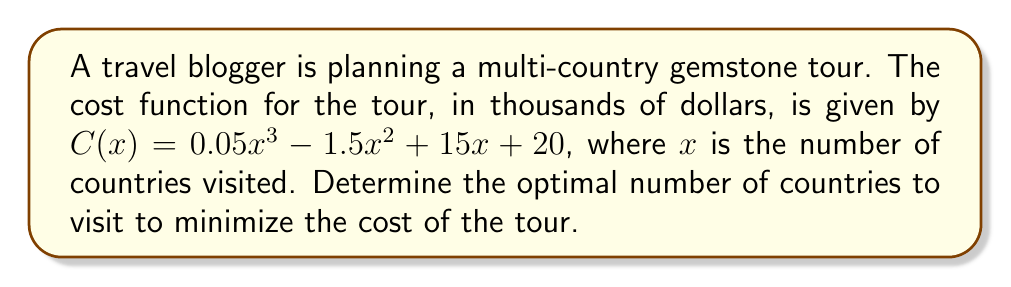Could you help me with this problem? To find the optimal number of countries that minimizes the cost, we need to find the minimum point of the cost function. This can be done by following these steps:

1. Find the derivative of the cost function:
   $$C'(x) = 0.15x^2 - 3x + 15$$

2. Set the derivative equal to zero and solve for x:
   $$0.15x^2 - 3x + 15 = 0$$

3. This is a quadratic equation. We can solve it using the quadratic formula:
   $$x = \frac{-b \pm \sqrt{b^2 - 4ac}}{2a}$$
   where $a = 0.15$, $b = -3$, and $c = 15$

4. Substituting these values:
   $$x = \frac{3 \pm \sqrt{9 - 4(0.15)(15)}}{2(0.15)}$$
   $$x = \frac{3 \pm \sqrt{9 - 9}}{0.3}$$
   $$x = \frac{3 \pm 0}{0.3}$$
   $$x = 10$$

5. To confirm this is a minimum, we can check the second derivative:
   $$C''(x) = 0.3x - 3$$
   $$C''(10) = 0.3(10) - 3 = 0$$
   Since $C''(10) > 0$, this confirms that $x = 10$ is a minimum point.

Therefore, the optimal number of countries to visit to minimize the cost is 10.
Answer: 10 countries 